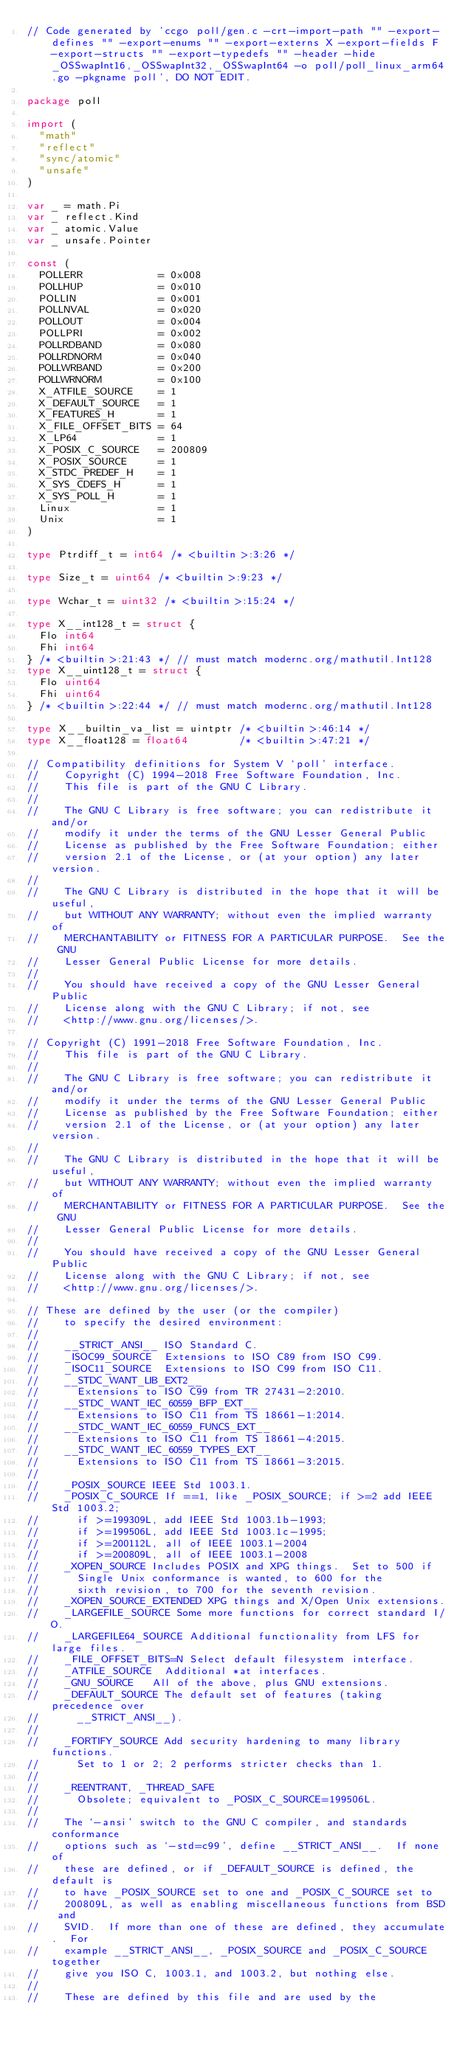Convert code to text. <code><loc_0><loc_0><loc_500><loc_500><_Go_>// Code generated by 'ccgo poll/gen.c -crt-import-path "" -export-defines "" -export-enums "" -export-externs X -export-fields F -export-structs "" -export-typedefs "" -header -hide _OSSwapInt16,_OSSwapInt32,_OSSwapInt64 -o poll/poll_linux_arm64.go -pkgname poll', DO NOT EDIT.

package poll

import (
	"math"
	"reflect"
	"sync/atomic"
	"unsafe"
)

var _ = math.Pi
var _ reflect.Kind
var _ atomic.Value
var _ unsafe.Pointer

const (
	POLLERR            = 0x008
	POLLHUP            = 0x010
	POLLIN             = 0x001
	POLLNVAL           = 0x020
	POLLOUT            = 0x004
	POLLPRI            = 0x002
	POLLRDBAND         = 0x080
	POLLRDNORM         = 0x040
	POLLWRBAND         = 0x200
	POLLWRNORM         = 0x100
	X_ATFILE_SOURCE    = 1
	X_DEFAULT_SOURCE   = 1
	X_FEATURES_H       = 1
	X_FILE_OFFSET_BITS = 64
	X_LP64             = 1
	X_POSIX_C_SOURCE   = 200809
	X_POSIX_SOURCE     = 1
	X_STDC_PREDEF_H    = 1
	X_SYS_CDEFS_H      = 1
	X_SYS_POLL_H       = 1
	Linux              = 1
	Unix               = 1
)

type Ptrdiff_t = int64 /* <builtin>:3:26 */

type Size_t = uint64 /* <builtin>:9:23 */

type Wchar_t = uint32 /* <builtin>:15:24 */

type X__int128_t = struct {
	Flo int64
	Fhi int64
} /* <builtin>:21:43 */ // must match modernc.org/mathutil.Int128
type X__uint128_t = struct {
	Flo uint64
	Fhi uint64
} /* <builtin>:22:44 */ // must match modernc.org/mathutil.Int128

type X__builtin_va_list = uintptr /* <builtin>:46:14 */
type X__float128 = float64        /* <builtin>:47:21 */

// Compatibility definitions for System V `poll' interface.
//    Copyright (C) 1994-2018 Free Software Foundation, Inc.
//    This file is part of the GNU C Library.
//
//    The GNU C Library is free software; you can redistribute it and/or
//    modify it under the terms of the GNU Lesser General Public
//    License as published by the Free Software Foundation; either
//    version 2.1 of the License, or (at your option) any later version.
//
//    The GNU C Library is distributed in the hope that it will be useful,
//    but WITHOUT ANY WARRANTY; without even the implied warranty of
//    MERCHANTABILITY or FITNESS FOR A PARTICULAR PURPOSE.  See the GNU
//    Lesser General Public License for more details.
//
//    You should have received a copy of the GNU Lesser General Public
//    License along with the GNU C Library; if not, see
//    <http://www.gnu.org/licenses/>.

// Copyright (C) 1991-2018 Free Software Foundation, Inc.
//    This file is part of the GNU C Library.
//
//    The GNU C Library is free software; you can redistribute it and/or
//    modify it under the terms of the GNU Lesser General Public
//    License as published by the Free Software Foundation; either
//    version 2.1 of the License, or (at your option) any later version.
//
//    The GNU C Library is distributed in the hope that it will be useful,
//    but WITHOUT ANY WARRANTY; without even the implied warranty of
//    MERCHANTABILITY or FITNESS FOR A PARTICULAR PURPOSE.  See the GNU
//    Lesser General Public License for more details.
//
//    You should have received a copy of the GNU Lesser General Public
//    License along with the GNU C Library; if not, see
//    <http://www.gnu.org/licenses/>.

// These are defined by the user (or the compiler)
//    to specify the desired environment:
//
//    __STRICT_ANSI__	ISO Standard C.
//    _ISOC99_SOURCE	Extensions to ISO C89 from ISO C99.
//    _ISOC11_SOURCE	Extensions to ISO C99 from ISO C11.
//    __STDC_WANT_LIB_EXT2__
// 			Extensions to ISO C99 from TR 27431-2:2010.
//    __STDC_WANT_IEC_60559_BFP_EXT__
// 			Extensions to ISO C11 from TS 18661-1:2014.
//    __STDC_WANT_IEC_60559_FUNCS_EXT__
// 			Extensions to ISO C11 from TS 18661-4:2015.
//    __STDC_WANT_IEC_60559_TYPES_EXT__
// 			Extensions to ISO C11 from TS 18661-3:2015.
//
//    _POSIX_SOURCE	IEEE Std 1003.1.
//    _POSIX_C_SOURCE	If ==1, like _POSIX_SOURCE; if >=2 add IEEE Std 1003.2;
// 			if >=199309L, add IEEE Std 1003.1b-1993;
// 			if >=199506L, add IEEE Std 1003.1c-1995;
// 			if >=200112L, all of IEEE 1003.1-2004
// 			if >=200809L, all of IEEE 1003.1-2008
//    _XOPEN_SOURCE	Includes POSIX and XPG things.  Set to 500 if
// 			Single Unix conformance is wanted, to 600 for the
// 			sixth revision, to 700 for the seventh revision.
//    _XOPEN_SOURCE_EXTENDED XPG things and X/Open Unix extensions.
//    _LARGEFILE_SOURCE	Some more functions for correct standard I/O.
//    _LARGEFILE64_SOURCE	Additional functionality from LFS for large files.
//    _FILE_OFFSET_BITS=N	Select default filesystem interface.
//    _ATFILE_SOURCE	Additional *at interfaces.
//    _GNU_SOURCE		All of the above, plus GNU extensions.
//    _DEFAULT_SOURCE	The default set of features (taking precedence over
// 			__STRICT_ANSI__).
//
//    _FORTIFY_SOURCE	Add security hardening to many library functions.
// 			Set to 1 or 2; 2 performs stricter checks than 1.
//
//    _REENTRANT, _THREAD_SAFE
// 			Obsolete; equivalent to _POSIX_C_SOURCE=199506L.
//
//    The `-ansi' switch to the GNU C compiler, and standards conformance
//    options such as `-std=c99', define __STRICT_ANSI__.  If none of
//    these are defined, or if _DEFAULT_SOURCE is defined, the default is
//    to have _POSIX_SOURCE set to one and _POSIX_C_SOURCE set to
//    200809L, as well as enabling miscellaneous functions from BSD and
//    SVID.  If more than one of these are defined, they accumulate.  For
//    example __STRICT_ANSI__, _POSIX_SOURCE and _POSIX_C_SOURCE together
//    give you ISO C, 1003.1, and 1003.2, but nothing else.
//
//    These are defined by this file and are used by the</code> 